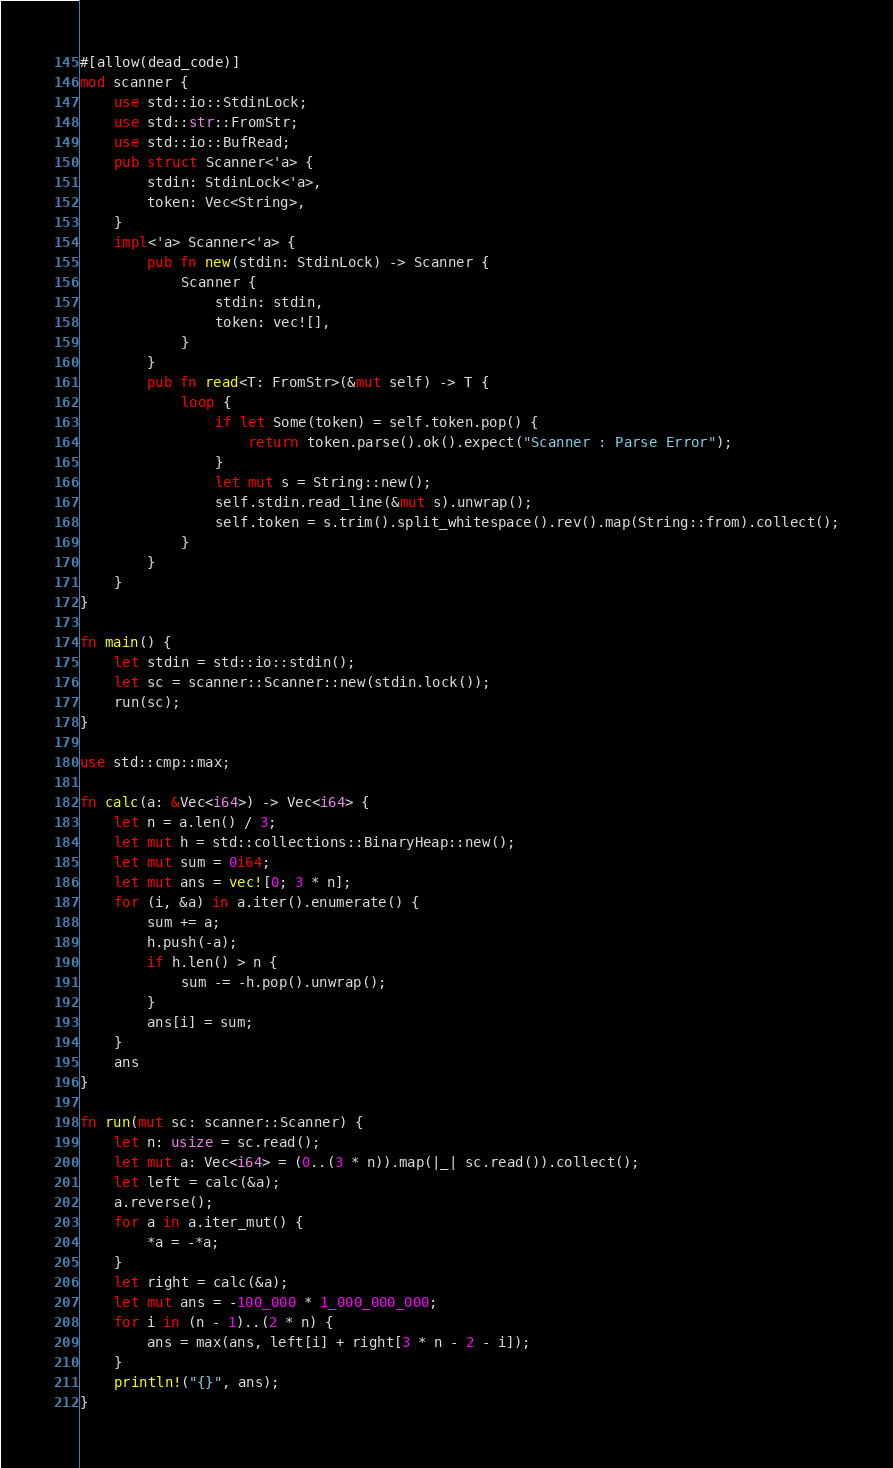Convert code to text. <code><loc_0><loc_0><loc_500><loc_500><_Rust_>#[allow(dead_code)]
mod scanner {
    use std::io::StdinLock;
    use std::str::FromStr;
    use std::io::BufRead;
    pub struct Scanner<'a> {
        stdin: StdinLock<'a>,
        token: Vec<String>,
    }
    impl<'a> Scanner<'a> {
        pub fn new(stdin: StdinLock) -> Scanner {
            Scanner {
                stdin: stdin,
                token: vec![],
            }
        }
        pub fn read<T: FromStr>(&mut self) -> T {
            loop {
                if let Some(token) = self.token.pop() {
                    return token.parse().ok().expect("Scanner : Parse Error");
                }
                let mut s = String::new();
                self.stdin.read_line(&mut s).unwrap();
                self.token = s.trim().split_whitespace().rev().map(String::from).collect();
            }
        }
    }
}

fn main() {
    let stdin = std::io::stdin();
    let sc = scanner::Scanner::new(stdin.lock());
    run(sc);
}

use std::cmp::max;

fn calc(a: &Vec<i64>) -> Vec<i64> {
    let n = a.len() / 3;
    let mut h = std::collections::BinaryHeap::new();
    let mut sum = 0i64;
    let mut ans = vec![0; 3 * n];
    for (i, &a) in a.iter().enumerate() {
        sum += a;
        h.push(-a);
        if h.len() > n {
            sum -= -h.pop().unwrap();
        }
        ans[i] = sum;
    }
    ans
}

fn run(mut sc: scanner::Scanner) {
    let n: usize = sc.read();
    let mut a: Vec<i64> = (0..(3 * n)).map(|_| sc.read()).collect();
    let left = calc(&a);
    a.reverse();
    for a in a.iter_mut() {
        *a = -*a;
    }
    let right = calc(&a);
    let mut ans = -100_000 * 1_000_000_000;
    for i in (n - 1)..(2 * n) {
        ans = max(ans, left[i] + right[3 * n - 2 - i]);
    }
    println!("{}", ans);
}
</code> 